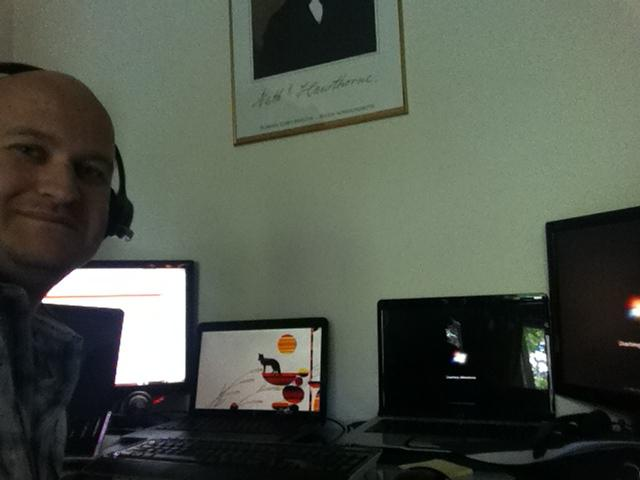What was installed on both the computers? windows 